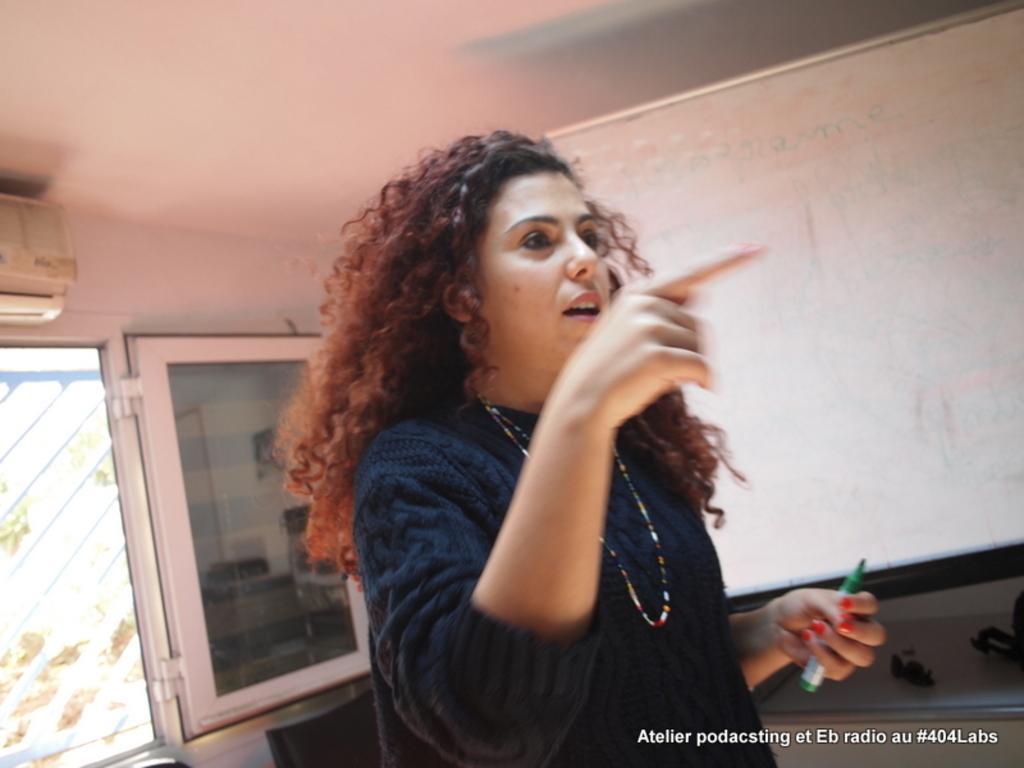How would you summarize this image in a sentence or two? This woman is pointing towards the right side of the image and holding a marker. Background we can see whiteboard, window glass door and air conditioner is on the wall. On this table there are things. Bottom of the image there is a watermark. 